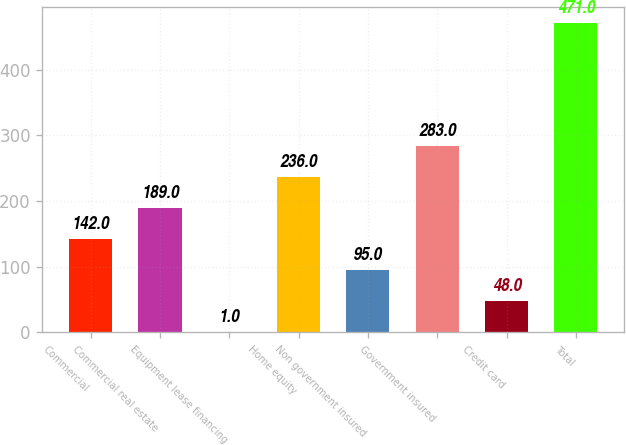<chart> <loc_0><loc_0><loc_500><loc_500><bar_chart><fcel>Commercial<fcel>Commercial real estate<fcel>Equipment lease financing<fcel>Home equity<fcel>Non government insured<fcel>Government insured<fcel>Credit card<fcel>Total<nl><fcel>142<fcel>189<fcel>1<fcel>236<fcel>95<fcel>283<fcel>48<fcel>471<nl></chart> 